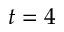<formula> <loc_0><loc_0><loc_500><loc_500>t = 4</formula> 